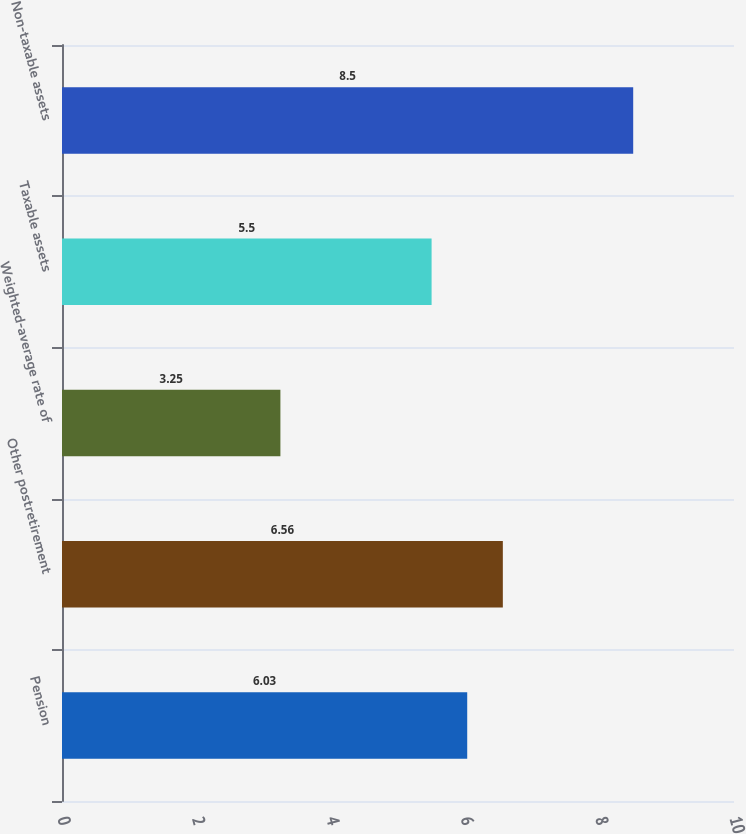<chart> <loc_0><loc_0><loc_500><loc_500><bar_chart><fcel>Pension<fcel>Other postretirement<fcel>Weighted-average rate of<fcel>Taxable assets<fcel>Non-taxable assets<nl><fcel>6.03<fcel>6.56<fcel>3.25<fcel>5.5<fcel>8.5<nl></chart> 